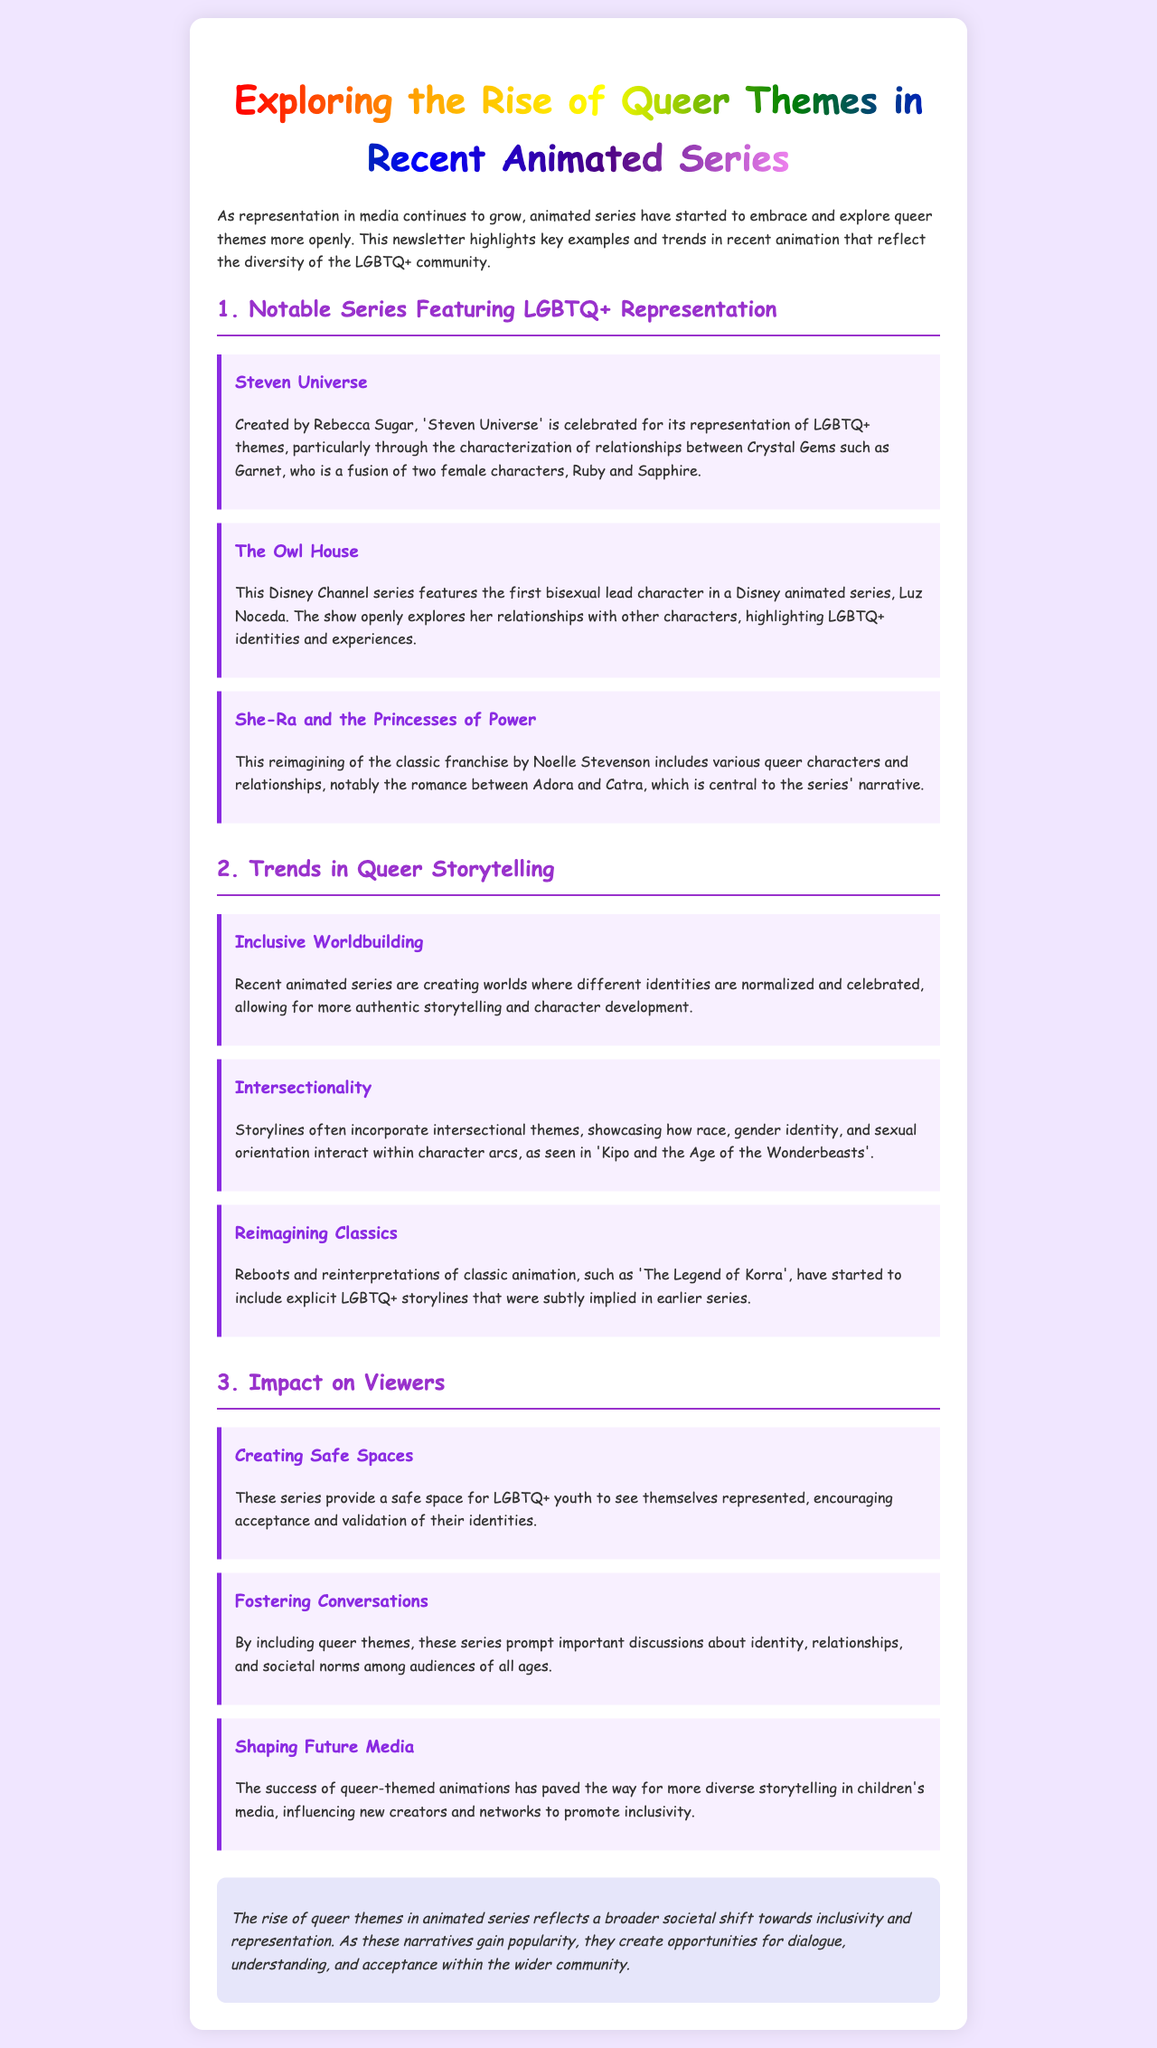What is the title of the newsletter? The title is mentioned prominently at the top of the document and is 'Exploring the Rise of Queer Themes in Recent Animated Series.'
Answer: Exploring the Rise of Queer Themes in Recent Animated Series Who created 'Steven Universe'? The creator of 'Steven Universe' is Rebecca Sugar, as stated in the section about notable series.
Answer: Rebecca Sugar What character is identified as the first bisexual lead in a Disney animated series? The document specifies Luz Noceda as the first bisexual lead in a Disney animated series from 'The Owl House'.
Answer: Luz Noceda Which series features the romance between Adora and Catra? The content item discusses the romance found in 'She-Ra and the Princesses of Power'.
Answer: She-Ra and the Princesses of Power What theme is highlighted in the section about Inclusive Worldbuilding? The document describes this theme as creating worlds where different identities are normalized and celebrated.
Answer: Normalized and celebrated What is a potential impact of including queer themes in animated series? The document states that these themes foster important discussions about identity, relationships, and societal norms.
Answer: Foster conversations Which term describes how recent animated series incorporate various identities interacting? The document refers to this concept as Intersectionality, which is discussed within the trends section.
Answer: Intersectionality What is the narrative significance of the reimagining of 'The Legend of Korra'? It includes explicit LGBTQ+ storylines that were subtly implied in earlier series, as mentioned in the document.
Answer: Explicit LGBTQ+ storylines What is the conclusion regarding the rise of queer themes in animated series? The conclusion notes that these narratives create opportunities for dialogue, understanding, and acceptance.
Answer: Opportunities for dialogue, understanding, and acceptance 